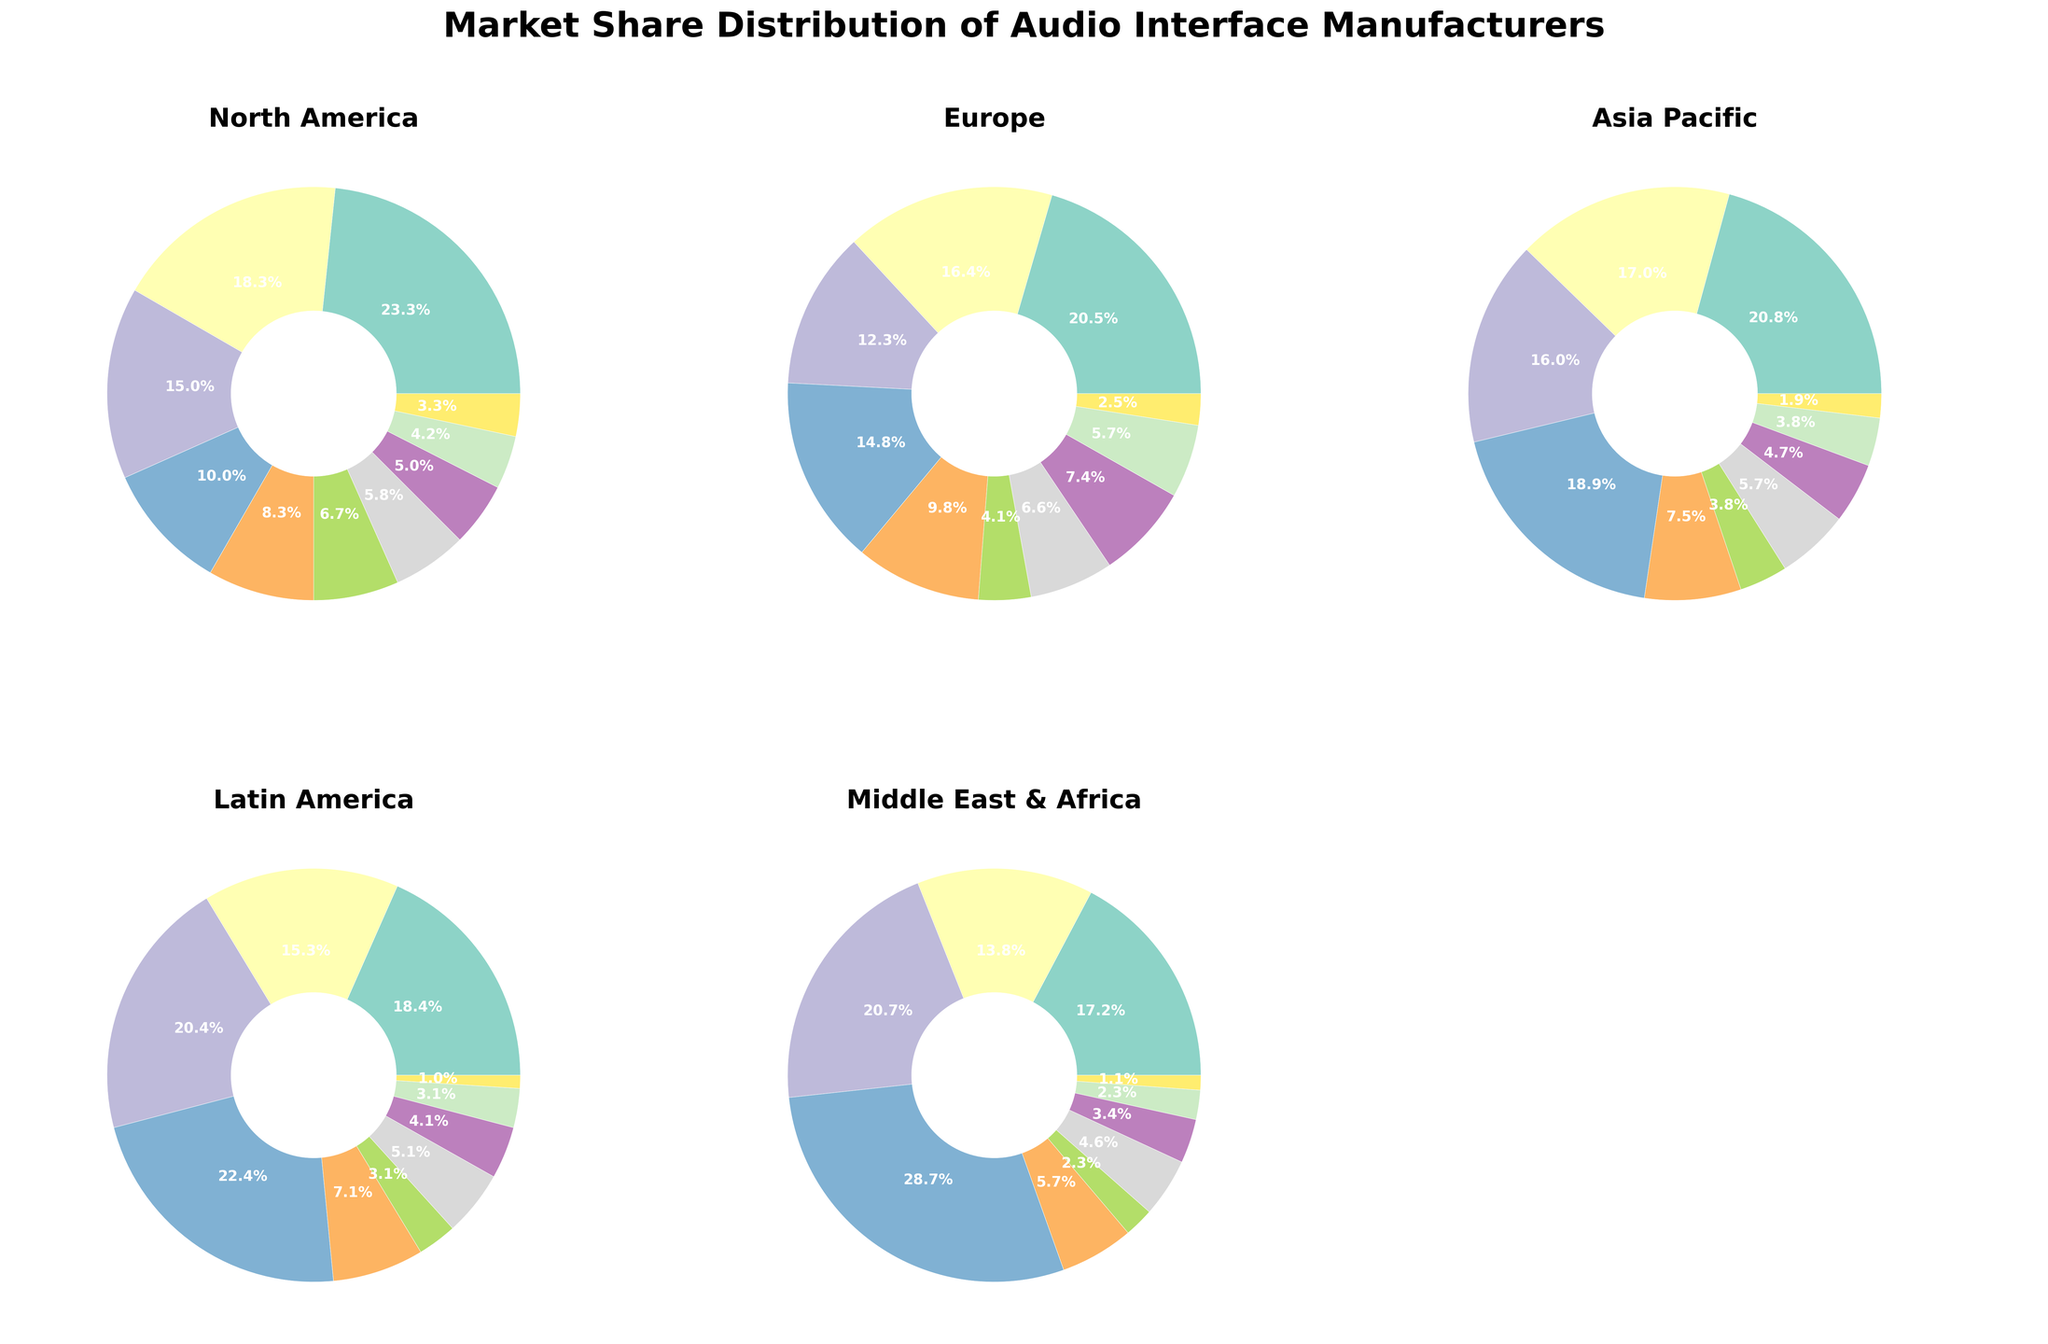Which manufacturer has the highest market share in Europe? By examining the pie chart for Europe, the slice with the largest percentage will indicate the manufacturer with the highest market share. Focusrite has a market share of 25% in Europe, which is the highest.
Answer: Focusrite Which two regions have the closest market share percentage for Behringer, and what are those percentages? Look at the slices for Behringer in each region and identify those with the closest percentages. Behringer has 22% in Asia Pacific and 22% in Latin America, which are the closest.
Answer: Asia Pacific and Latin America, both 22% What is the total market share percentage of Focusrite in North America and Europe combined? Add the market share percentages of Focusrite in North America and Europe: 28% + 25%. Therefore, the total is 53%.
Answer: 53% Which manufacturer has the smallest market share in the Middle East & Africa, and what is that percentage? By checking the pie chart for the Middle East & Africa, look for the manufacturer with the smallest slice. Solid State Logic has the smallest share with 1%.
Answer: Solid State Logic, 1% How does the market share of Universal Audio in Latin America compare to that in the Middle East & Africa? Find the percentages for Universal Audio in both regions and compare them. Universal Audio has a market share of 15% in Latin America and 12% in the Middle East & Africa, showing it is higher in Latin America.
Answer: Higher in Latin America What is the market share difference for PreSonus between North America and Europe? Subtract the market share of PreSonus in Europe from its share in North America: 18% - 15%. The difference is 3%.
Answer: 3% Which region has the most even distribution of market shares across all manufacturers? Examine each pie chart to see which region has the least variation in slice sizes, indicating an even distribution. Asia Pacific appears to have a more even spread compared to other regions.
Answer: Asia Pacific In which region does Native Instruments have the highest market share? Check each pie chart for the slice representing Native Instruments and identify the one with the largest percentage. Native Instruments has the highest market share in Europe at 12%.
Answer: Europe What is the combined market share of Apogee, MOTU, and RME in the Middle East & Africa? Add the market share percentages of Apogee, MOTU, and RME in the Middle East & Africa: 2% + 4% + 3%. The total is 9%.
Answer: 9% Which regions have a market share percentage higher for Solid State Logic than Apogee, and what are the differences? Compare the market shares between Apogee and Solid State Logic for each region. Only in North America does Solid State Logic (4%) have a market share higher than Apogee (3%), with a difference of 1%.
Answer: North America, 1% higher 